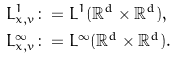<formula> <loc_0><loc_0><loc_500><loc_500>L ^ { 1 } _ { x , v } & \colon = L ^ { 1 } ( \mathbb { R } ^ { d } \times \mathbb { R } ^ { d } ) , \\ L ^ { \infty } _ { x , v } & \colon = L ^ { \infty } ( \mathbb { R } ^ { d } \times \mathbb { R } ^ { d } ) .</formula> 